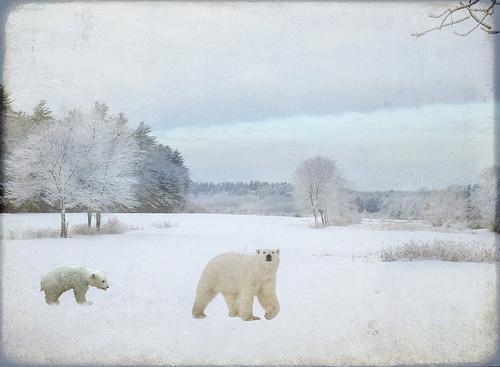How many bears are in the picture?
Give a very brief answer. 2. 